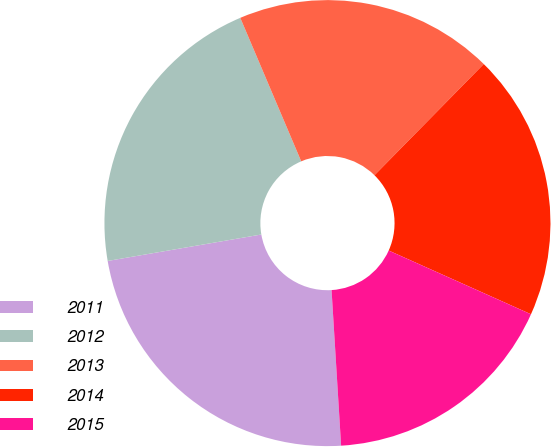Convert chart. <chart><loc_0><loc_0><loc_500><loc_500><pie_chart><fcel>2011<fcel>2012<fcel>2013<fcel>2014<fcel>2015<nl><fcel>23.26%<fcel>21.32%<fcel>18.75%<fcel>19.34%<fcel>17.32%<nl></chart> 